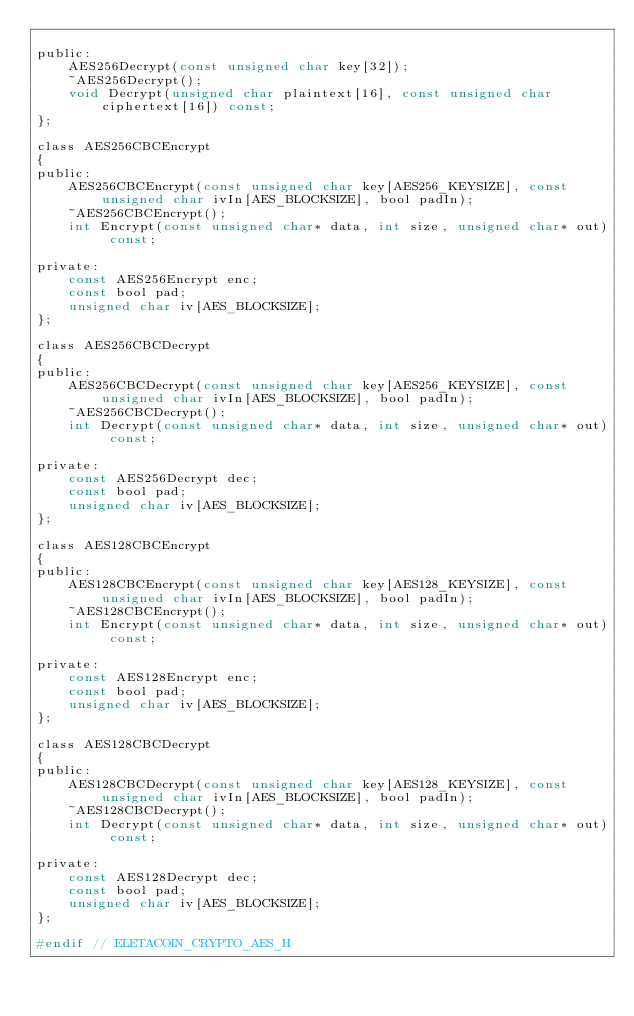<code> <loc_0><loc_0><loc_500><loc_500><_C_>
public:
    AES256Decrypt(const unsigned char key[32]);
    ~AES256Decrypt();
    void Decrypt(unsigned char plaintext[16], const unsigned char ciphertext[16]) const;
};

class AES256CBCEncrypt
{
public:
    AES256CBCEncrypt(const unsigned char key[AES256_KEYSIZE], const unsigned char ivIn[AES_BLOCKSIZE], bool padIn);
    ~AES256CBCEncrypt();
    int Encrypt(const unsigned char* data, int size, unsigned char* out) const;

private:
    const AES256Encrypt enc;
    const bool pad;
    unsigned char iv[AES_BLOCKSIZE];
};

class AES256CBCDecrypt
{
public:
    AES256CBCDecrypt(const unsigned char key[AES256_KEYSIZE], const unsigned char ivIn[AES_BLOCKSIZE], bool padIn);
    ~AES256CBCDecrypt();
    int Decrypt(const unsigned char* data, int size, unsigned char* out) const;

private:
    const AES256Decrypt dec;
    const bool pad;
    unsigned char iv[AES_BLOCKSIZE];
};

class AES128CBCEncrypt
{
public:
    AES128CBCEncrypt(const unsigned char key[AES128_KEYSIZE], const unsigned char ivIn[AES_BLOCKSIZE], bool padIn);
    ~AES128CBCEncrypt();
    int Encrypt(const unsigned char* data, int size, unsigned char* out) const;

private:
    const AES128Encrypt enc;
    const bool pad;
    unsigned char iv[AES_BLOCKSIZE];
};

class AES128CBCDecrypt
{
public:
    AES128CBCDecrypt(const unsigned char key[AES128_KEYSIZE], const unsigned char ivIn[AES_BLOCKSIZE], bool padIn);
    ~AES128CBCDecrypt();
    int Decrypt(const unsigned char* data, int size, unsigned char* out) const;

private:
    const AES128Decrypt dec;
    const bool pad;
    unsigned char iv[AES_BLOCKSIZE];
};

#endif // ELETACOIN_CRYPTO_AES_H
</code> 